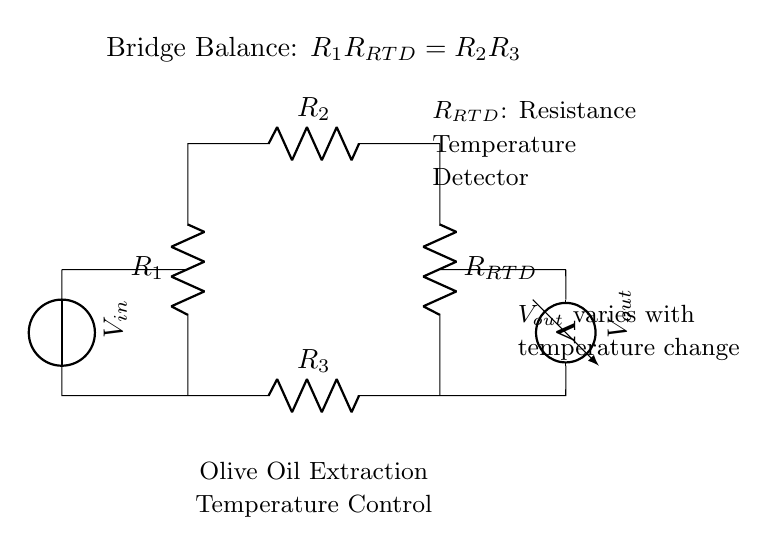What is the type of temperature sensor used in this circuit? The circuit diagram indicates a Resistance Temperature Detector, denoted as RRTD, which is a type of temperature sensor that measures temperature changes by correlating the resistance of the sensor with temperature.
Answer: Resistance Temperature Detector What is the relationship defined by the bridge balance equation? The equation R1 multiplied by RRTD equals R2 multiplied by R3 shows the condition for the bridge to be balanced. This means that when the resistance of the RTD changes with temperature, the values of R1, R2, and R3 can be adjusted to maintain balance, thus allowing for accurate temperature measurement.
Answer: R1RRTD = R2R3 What does Vout represent in the circuit? In the bridge circuit, Vout represents the output voltage, which varies based on the resistance change of the RRTD with respect to temperature variations. This variation in voltage is what gets measured to determine the temperature.
Answer: Output voltage How many resistors are present in this circuit diagram? The circuit contains four resistors: R1, R2, R3, and RRTD. Each resistor contributes to the overall behavior of the bridge circuit and assists in temperature measurement through the RTD sensor.
Answer: Four What kind of circuit configuration is used in this diagram? The diagram implements a bridge circuit configuration, specifically a Wheatstone bridge, which is designed for precise measurements of resistance changes caused by variations in temperature from the RTD.
Answer: Bridge circuit Which component is responsible for detecting the temperature? The RTD, or Resistance Temperature Detector, is the primary component responsible for detecting changes in temperature by measuring the change in its resistance as temperature varies.
Answer: RTD 